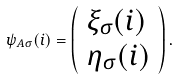Convert formula to latex. <formula><loc_0><loc_0><loc_500><loc_500>\psi _ { A \sigma } ( i ) = \left ( \begin{array} { l } \xi _ { \sigma } ( i ) \\ \eta _ { \sigma } ( i ) \end{array} \right ) .</formula> 